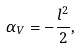Convert formula to latex. <formula><loc_0><loc_0><loc_500><loc_500>\alpha _ { V } = - \frac { l ^ { 2 } } { 2 } , \,</formula> 